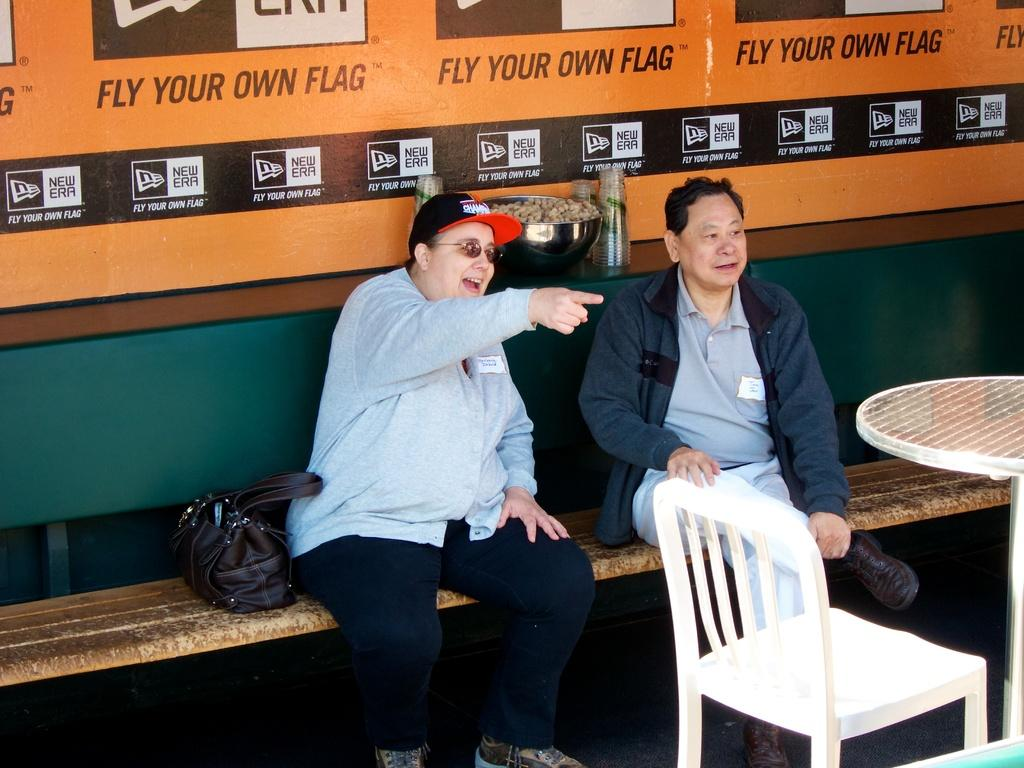How many people are sitting on the bench in the image? There are two persons sitting on a bench in the image. What is located beside the persons on the bench? There is a handbag and a chair beside the persons on the bench. What other piece of furniture is present beside the persons? There is a table beside the persons. What can be seen in the background of the image? There are objects visible in the background of the image. How many feathers can be seen floating in the stream in the image? There is no stream present in the image, and therefore no feathers can be seen floating in it. 